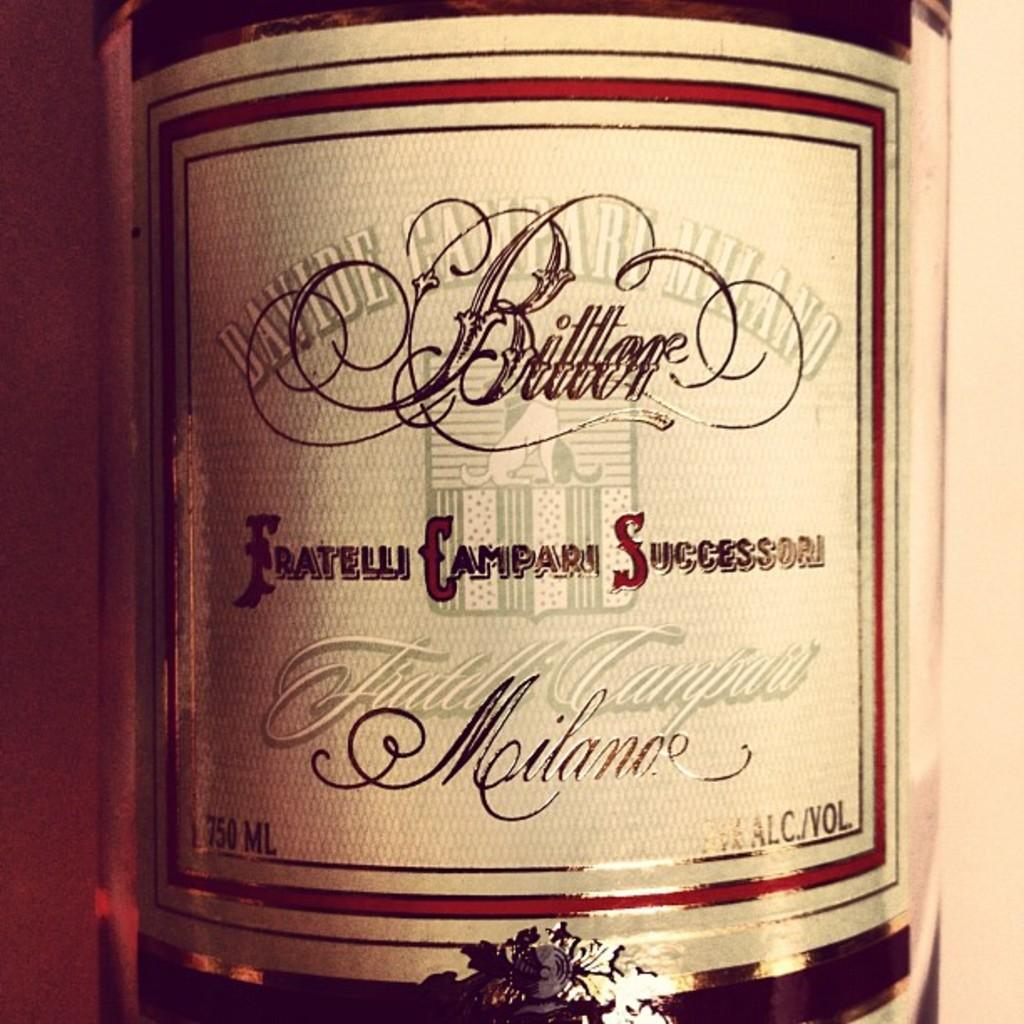Provide a one-sentence caption for the provided image. The amount of fluid in the container is 750ML. 